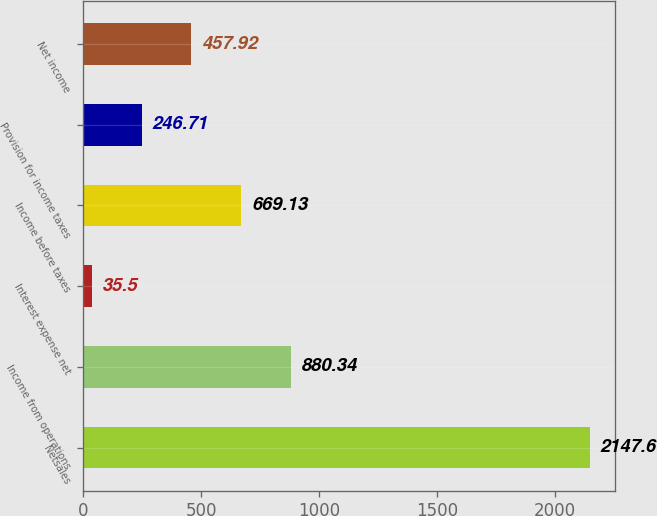Convert chart. <chart><loc_0><loc_0><loc_500><loc_500><bar_chart><fcel>Netsales<fcel>Income from operations<fcel>Interest expense net<fcel>Income before taxes<fcel>Provision for income taxes<fcel>Net income<nl><fcel>2147.6<fcel>880.34<fcel>35.5<fcel>669.13<fcel>246.71<fcel>457.92<nl></chart> 